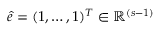<formula> <loc_0><loc_0><loc_500><loc_500>\hat { e } = ( 1 , \dots , 1 ) ^ { T } \in \mathbb { R } ^ { ( s - 1 ) }</formula> 